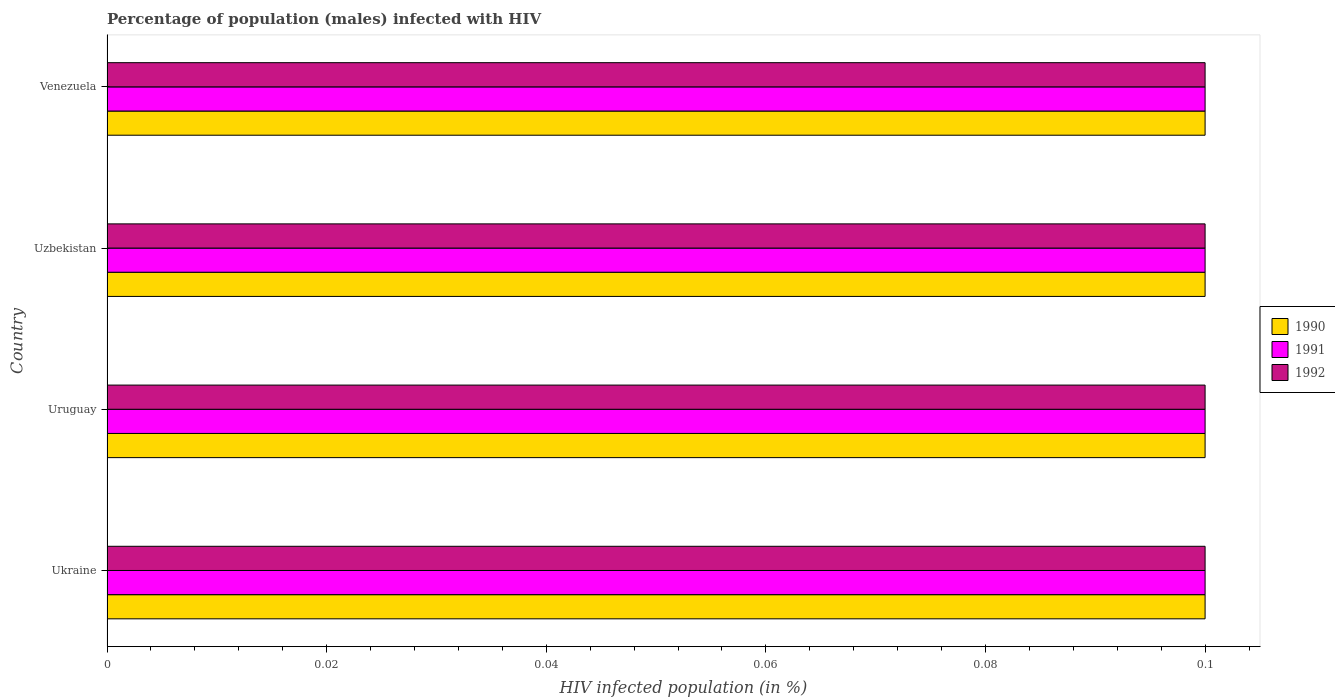How many different coloured bars are there?
Your answer should be very brief. 3. Are the number of bars per tick equal to the number of legend labels?
Your response must be concise. Yes. How many bars are there on the 1st tick from the top?
Make the answer very short. 3. What is the label of the 3rd group of bars from the top?
Your answer should be compact. Uruguay. In which country was the percentage of HIV infected male population in 1992 maximum?
Keep it short and to the point. Ukraine. In which country was the percentage of HIV infected male population in 1992 minimum?
Offer a terse response. Ukraine. What is the average percentage of HIV infected male population in 1992 per country?
Ensure brevity in your answer.  0.1. What is the difference between the percentage of HIV infected male population in 1992 and percentage of HIV infected male population in 1991 in Ukraine?
Give a very brief answer. 0. Is the percentage of HIV infected male population in 1990 in Uruguay less than that in Uzbekistan?
Provide a succinct answer. No. Is the difference between the percentage of HIV infected male population in 1992 in Ukraine and Uzbekistan greater than the difference between the percentage of HIV infected male population in 1991 in Ukraine and Uzbekistan?
Your response must be concise. No. What is the difference between the highest and the second highest percentage of HIV infected male population in 1992?
Give a very brief answer. 0. What is the difference between the highest and the lowest percentage of HIV infected male population in 1992?
Keep it short and to the point. 0. In how many countries, is the percentage of HIV infected male population in 1991 greater than the average percentage of HIV infected male population in 1991 taken over all countries?
Ensure brevity in your answer.  0. Is the sum of the percentage of HIV infected male population in 1991 in Uruguay and Uzbekistan greater than the maximum percentage of HIV infected male population in 1992 across all countries?
Make the answer very short. Yes. What does the 2nd bar from the top in Venezuela represents?
Make the answer very short. 1991. How many bars are there?
Make the answer very short. 12. Are all the bars in the graph horizontal?
Provide a succinct answer. Yes. Are the values on the major ticks of X-axis written in scientific E-notation?
Offer a very short reply. No. Does the graph contain any zero values?
Your answer should be very brief. No. How are the legend labels stacked?
Give a very brief answer. Vertical. What is the title of the graph?
Give a very brief answer. Percentage of population (males) infected with HIV. What is the label or title of the X-axis?
Provide a short and direct response. HIV infected population (in %). What is the label or title of the Y-axis?
Offer a terse response. Country. What is the HIV infected population (in %) of 1991 in Ukraine?
Offer a very short reply. 0.1. What is the HIV infected population (in %) in 1992 in Ukraine?
Provide a succinct answer. 0.1. What is the HIV infected population (in %) in 1990 in Uruguay?
Your response must be concise. 0.1. What is the HIV infected population (in %) of 1991 in Uruguay?
Your response must be concise. 0.1. What is the HIV infected population (in %) of 1992 in Uzbekistan?
Offer a very short reply. 0.1. What is the HIV infected population (in %) of 1990 in Venezuela?
Offer a terse response. 0.1. What is the HIV infected population (in %) in 1991 in Venezuela?
Provide a succinct answer. 0.1. What is the HIV infected population (in %) of 1992 in Venezuela?
Provide a succinct answer. 0.1. Across all countries, what is the maximum HIV infected population (in %) of 1990?
Your answer should be compact. 0.1. Across all countries, what is the maximum HIV infected population (in %) in 1991?
Your answer should be very brief. 0.1. What is the total HIV infected population (in %) of 1990 in the graph?
Your answer should be very brief. 0.4. What is the total HIV infected population (in %) of 1991 in the graph?
Your response must be concise. 0.4. What is the difference between the HIV infected population (in %) of 1991 in Ukraine and that in Uruguay?
Your response must be concise. 0. What is the difference between the HIV infected population (in %) in 1992 in Ukraine and that in Uruguay?
Give a very brief answer. 0. What is the difference between the HIV infected population (in %) in 1990 in Ukraine and that in Uzbekistan?
Ensure brevity in your answer.  0. What is the difference between the HIV infected population (in %) of 1992 in Ukraine and that in Uzbekistan?
Your answer should be compact. 0. What is the difference between the HIV infected population (in %) of 1990 in Uruguay and that in Uzbekistan?
Your answer should be very brief. 0. What is the difference between the HIV infected population (in %) in 1992 in Uruguay and that in Uzbekistan?
Offer a very short reply. 0. What is the difference between the HIV infected population (in %) in 1991 in Uruguay and that in Venezuela?
Ensure brevity in your answer.  0. What is the difference between the HIV infected population (in %) in 1992 in Uzbekistan and that in Venezuela?
Your answer should be compact. 0. What is the difference between the HIV infected population (in %) of 1991 in Ukraine and the HIV infected population (in %) of 1992 in Uruguay?
Give a very brief answer. 0. What is the difference between the HIV infected population (in %) in 1990 in Ukraine and the HIV infected population (in %) in 1991 in Uzbekistan?
Your answer should be very brief. 0. What is the difference between the HIV infected population (in %) in 1991 in Ukraine and the HIV infected population (in %) in 1992 in Uzbekistan?
Make the answer very short. 0. What is the difference between the HIV infected population (in %) of 1990 in Ukraine and the HIV infected population (in %) of 1991 in Venezuela?
Give a very brief answer. 0. What is the difference between the HIV infected population (in %) of 1990 in Uruguay and the HIV infected population (in %) of 1992 in Uzbekistan?
Make the answer very short. 0. What is the difference between the HIV infected population (in %) in 1990 in Uruguay and the HIV infected population (in %) in 1991 in Venezuela?
Give a very brief answer. 0. What is the difference between the HIV infected population (in %) of 1990 in Uzbekistan and the HIV infected population (in %) of 1992 in Venezuela?
Your answer should be compact. 0. What is the difference between the HIV infected population (in %) of 1990 and HIV infected population (in %) of 1991 in Ukraine?
Provide a short and direct response. 0. What is the difference between the HIV infected population (in %) in 1990 and HIV infected population (in %) in 1991 in Uruguay?
Offer a very short reply. 0. What is the difference between the HIV infected population (in %) of 1990 and HIV infected population (in %) of 1991 in Uzbekistan?
Your answer should be very brief. 0. What is the difference between the HIV infected population (in %) in 1990 and HIV infected population (in %) in 1991 in Venezuela?
Keep it short and to the point. 0. What is the difference between the HIV infected population (in %) of 1990 and HIV infected population (in %) of 1992 in Venezuela?
Provide a short and direct response. 0. What is the ratio of the HIV infected population (in %) of 1991 in Ukraine to that in Venezuela?
Your answer should be very brief. 1. What is the ratio of the HIV infected population (in %) of 1991 in Uruguay to that in Uzbekistan?
Your response must be concise. 1. What is the ratio of the HIV infected population (in %) of 1992 in Uruguay to that in Venezuela?
Your answer should be very brief. 1. What is the ratio of the HIV infected population (in %) of 1990 in Uzbekistan to that in Venezuela?
Offer a very short reply. 1. What is the difference between the highest and the lowest HIV infected population (in %) in 1991?
Your response must be concise. 0. What is the difference between the highest and the lowest HIV infected population (in %) in 1992?
Provide a succinct answer. 0. 